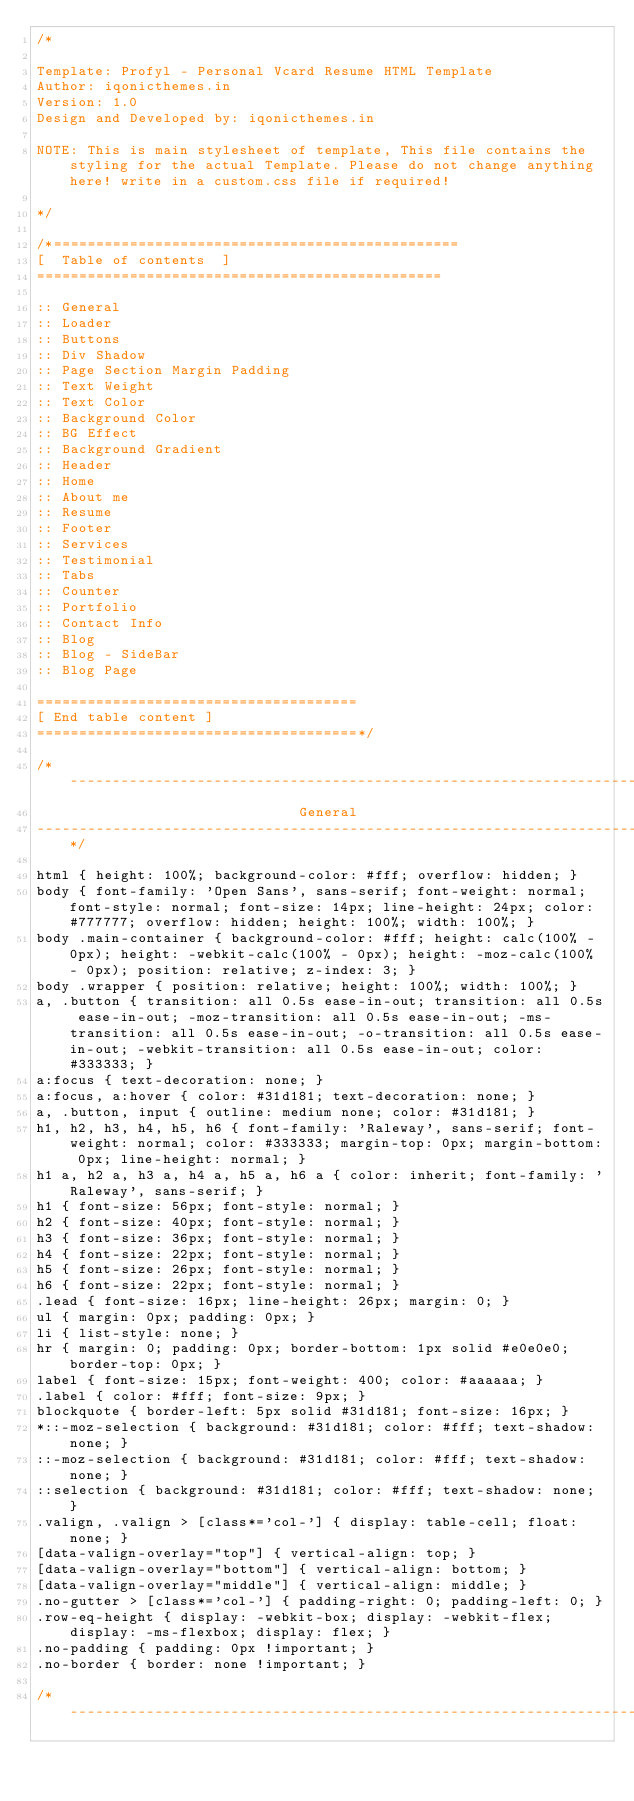Convert code to text. <code><loc_0><loc_0><loc_500><loc_500><_CSS_>/*

Template: Profyl - Personal Vcard Resume HTML Template
Author: iqonicthemes.in
Version: 1.0
Design and Developed by: iqonicthemes.in

NOTE: This is main stylesheet of template, This file contains the styling for the actual Template. Please do not change anything here! write in a custom.css file if required!

*/

/*================================================
[  Table of contents  ]
================================================

:: General
:: Loader
:: Buttons
:: Div Shadow
:: Page Section Margin Padding
:: Text Weight
:: Text Color
:: Background Color
:: BG Effect
:: Background Gradient
:: Header
:: Home
:: About me
:: Resume
:: Footer
:: Services
:: Testimonial
:: Tabs
:: Counter
:: Portfolio
:: Contact Info
:: Blog
:: Blog - SideBar
:: Blog Page

======================================
[ End table content ]
======================================*/

/*---------------------------------------------------------------------
                               General
-----------------------------------------------------------------------*/

html { height: 100%; background-color: #fff; overflow: hidden; }
body { font-family: 'Open Sans', sans-serif; font-weight: normal; font-style: normal; font-size: 14px; line-height: 24px; color: #777777; overflow: hidden; height: 100%; width: 100%; }
body .main-container { background-color: #fff; height: calc(100% - 0px); height: -webkit-calc(100% - 0px); height: -moz-calc(100% - 0px); position: relative; z-index: 3; }
body .wrapper { position: relative; height: 100%; width: 100%; }
a, .button { transition: all 0.5s ease-in-out; transition: all 0.5s ease-in-out; -moz-transition: all 0.5s ease-in-out; -ms-transition: all 0.5s ease-in-out; -o-transition: all 0.5s ease-in-out; -webkit-transition: all 0.5s ease-in-out; color: #333333; }
a:focus { text-decoration: none; }
a:focus, a:hover { color: #31d181; text-decoration: none; }
a, .button, input { outline: medium none; color: #31d181; }
h1, h2, h3, h4, h5, h6 { font-family: 'Raleway', sans-serif; font-weight: normal; color: #333333; margin-top: 0px; margin-bottom: 0px; line-height: normal; }
h1 a, h2 a, h3 a, h4 a, h5 a, h6 a { color: inherit; font-family: 'Raleway', sans-serif; }
h1 { font-size: 56px; font-style: normal; }
h2 { font-size: 40px; font-style: normal; }
h3 { font-size: 36px; font-style: normal; }
h4 { font-size: 22px; font-style: normal; }
h5 { font-size: 26px; font-style: normal; }
h6 { font-size: 22px; font-style: normal; }
.lead { font-size: 16px; line-height: 26px; margin: 0; }
ul { margin: 0px; padding: 0px; }
li { list-style: none; }
hr { margin: 0; padding: 0px; border-bottom: 1px solid #e0e0e0; border-top: 0px; }
label { font-size: 15px; font-weight: 400; color: #aaaaaa; }
.label { color: #fff; font-size: 9px; }
blockquote { border-left: 5px solid #31d181; font-size: 16px; }
*::-moz-selection { background: #31d181; color: #fff; text-shadow: none; }
::-moz-selection { background: #31d181; color: #fff; text-shadow: none; }
::selection { background: #31d181; color: #fff; text-shadow: none; }
.valign, .valign > [class*='col-'] { display: table-cell; float: none; }
[data-valign-overlay="top"] { vertical-align: top; }
[data-valign-overlay="bottom"] { vertical-align: bottom; }
[data-valign-overlay="middle"] { vertical-align: middle; }
.no-gutter > [class*='col-'] { padding-right: 0; padding-left: 0; }
.row-eq-height { display: -webkit-box; display: -webkit-flex; display: -ms-flexbox; display: flex; }
.no-padding { padding: 0px !important; }
.no-border { border: none !important; }

/*---------------------------------------------------------------------</code> 